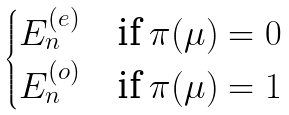Convert formula to latex. <formula><loc_0><loc_0><loc_500><loc_500>\begin{cases} E _ { n } ^ { ( e ) } & \text {if $\pi(\mu) = 0$} \\ E _ { n } ^ { ( o ) } & \text {if $\pi(\mu) = 1$} \end{cases}</formula> 